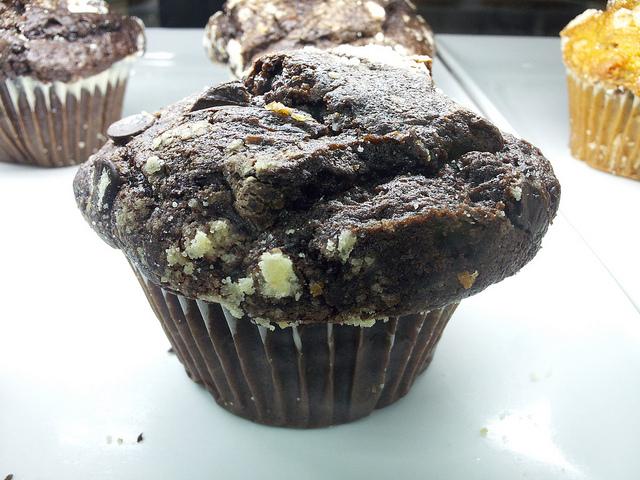What type of food is this?
Concise answer only. Muffin. How many cupcakes are there?
Be succinct. 4. What color is the table?
Concise answer only. White. 